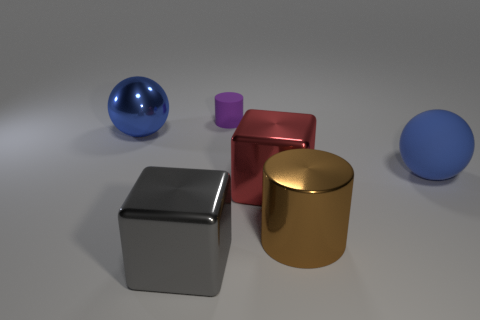Add 2 big purple cylinders. How many objects exist? 8 Subtract 1 cubes. How many cubes are left? 1 Subtract 0 gray cylinders. How many objects are left? 6 Subtract all gray spheres. Subtract all blue blocks. How many spheres are left? 2 Subtract all large cyan shiny cylinders. Subtract all blocks. How many objects are left? 4 Add 6 big blocks. How many big blocks are left? 8 Add 4 large green matte cylinders. How many large green matte cylinders exist? 4 